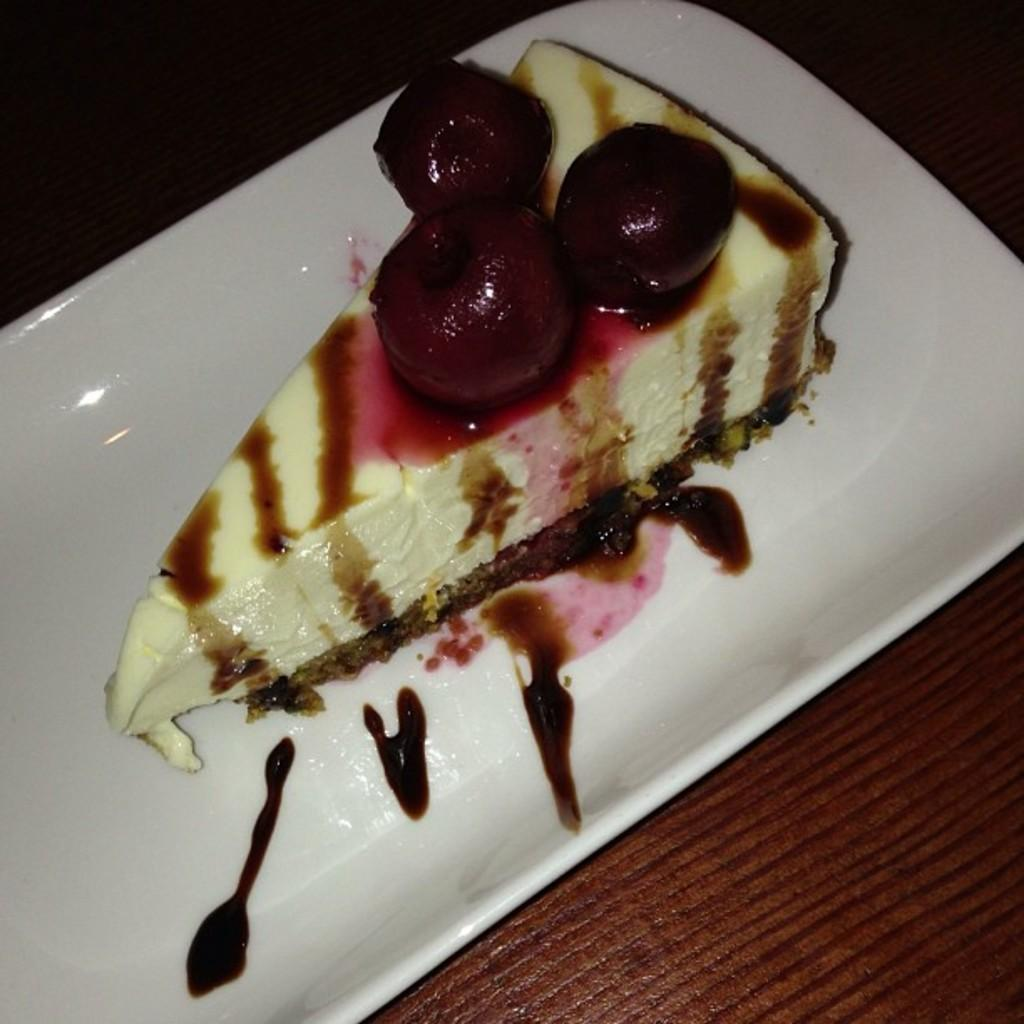What is the main subject of the image? There is a cake on a plate in the image. Can you describe the surface on which the plate is placed? The plate is placed on a wooden surface. What type of bun is being used as a source of authority in the image? There is no bun or reference to authority present in the image. 